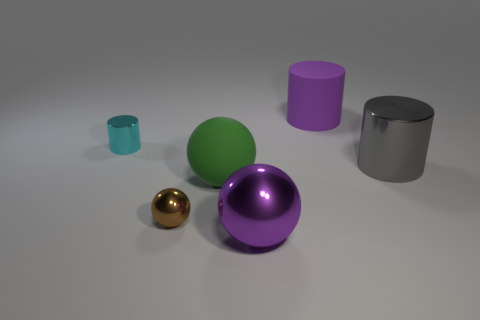Add 3 large matte cylinders. How many objects exist? 9 Subtract all large balls. How many balls are left? 1 Subtract all cyan cylinders. How many cylinders are left? 2 Subtract all gray spheres. How many purple cylinders are left? 1 Subtract all small metallic objects. Subtract all small cylinders. How many objects are left? 3 Add 5 small brown metallic things. How many small brown metallic things are left? 6 Add 2 big yellow rubber cubes. How many big yellow rubber cubes exist? 2 Subtract 0 yellow cylinders. How many objects are left? 6 Subtract 2 balls. How many balls are left? 1 Subtract all green cylinders. Subtract all yellow balls. How many cylinders are left? 3 